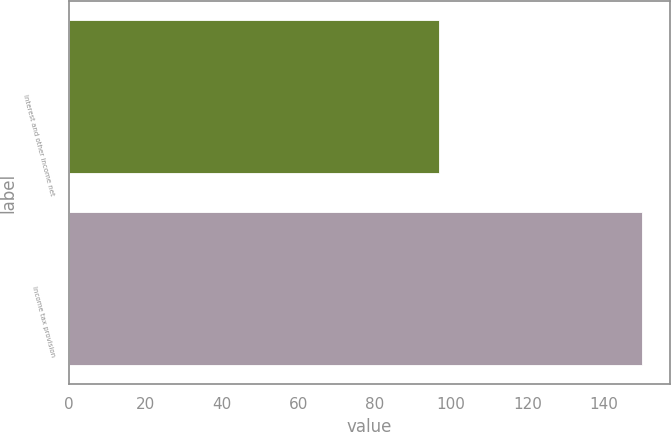<chart> <loc_0><loc_0><loc_500><loc_500><bar_chart><fcel>Interest and other income net<fcel>Income tax provision<nl><fcel>96.8<fcel>149.8<nl></chart> 